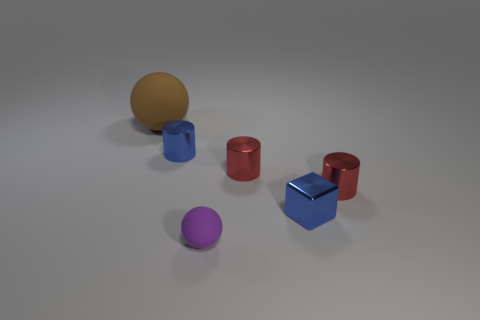What material is the tiny cylinder that is the same color as the tiny cube?
Keep it short and to the point. Metal. Is the number of rubber balls that are left of the tiny matte thing greater than the number of blue shiny blocks that are left of the tiny blue cube?
Provide a succinct answer. Yes. Do the tiny cylinder that is right of the shiny cube and the cube have the same color?
Ensure brevity in your answer.  No. What is the size of the blue cube?
Offer a terse response. Small. There is a blue thing that is the same size as the blue cube; what is its material?
Give a very brief answer. Metal. What is the color of the ball in front of the large rubber object?
Your answer should be very brief. Purple. What number of small red cylinders are there?
Ensure brevity in your answer.  2. Are there any blue cubes that are left of the small blue metal thing in front of the tiny object that is to the left of the tiny purple matte thing?
Offer a terse response. No. What is the shape of the blue metal object that is the same size as the block?
Give a very brief answer. Cylinder. How many other things are there of the same color as the small shiny cube?
Offer a very short reply. 1. 